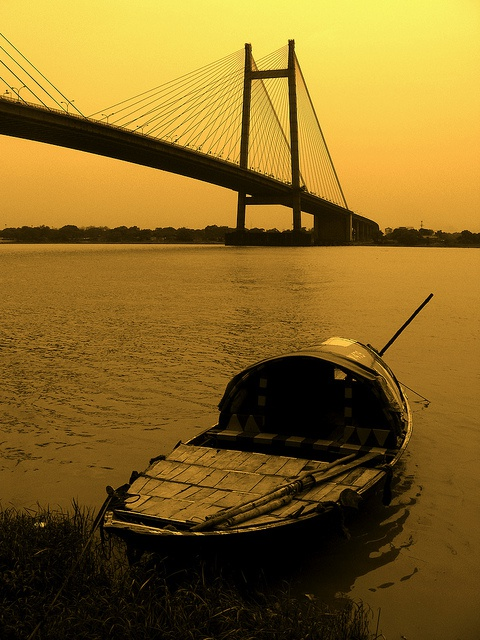Describe the objects in this image and their specific colors. I can see a boat in gold, black, olive, and maroon tones in this image. 